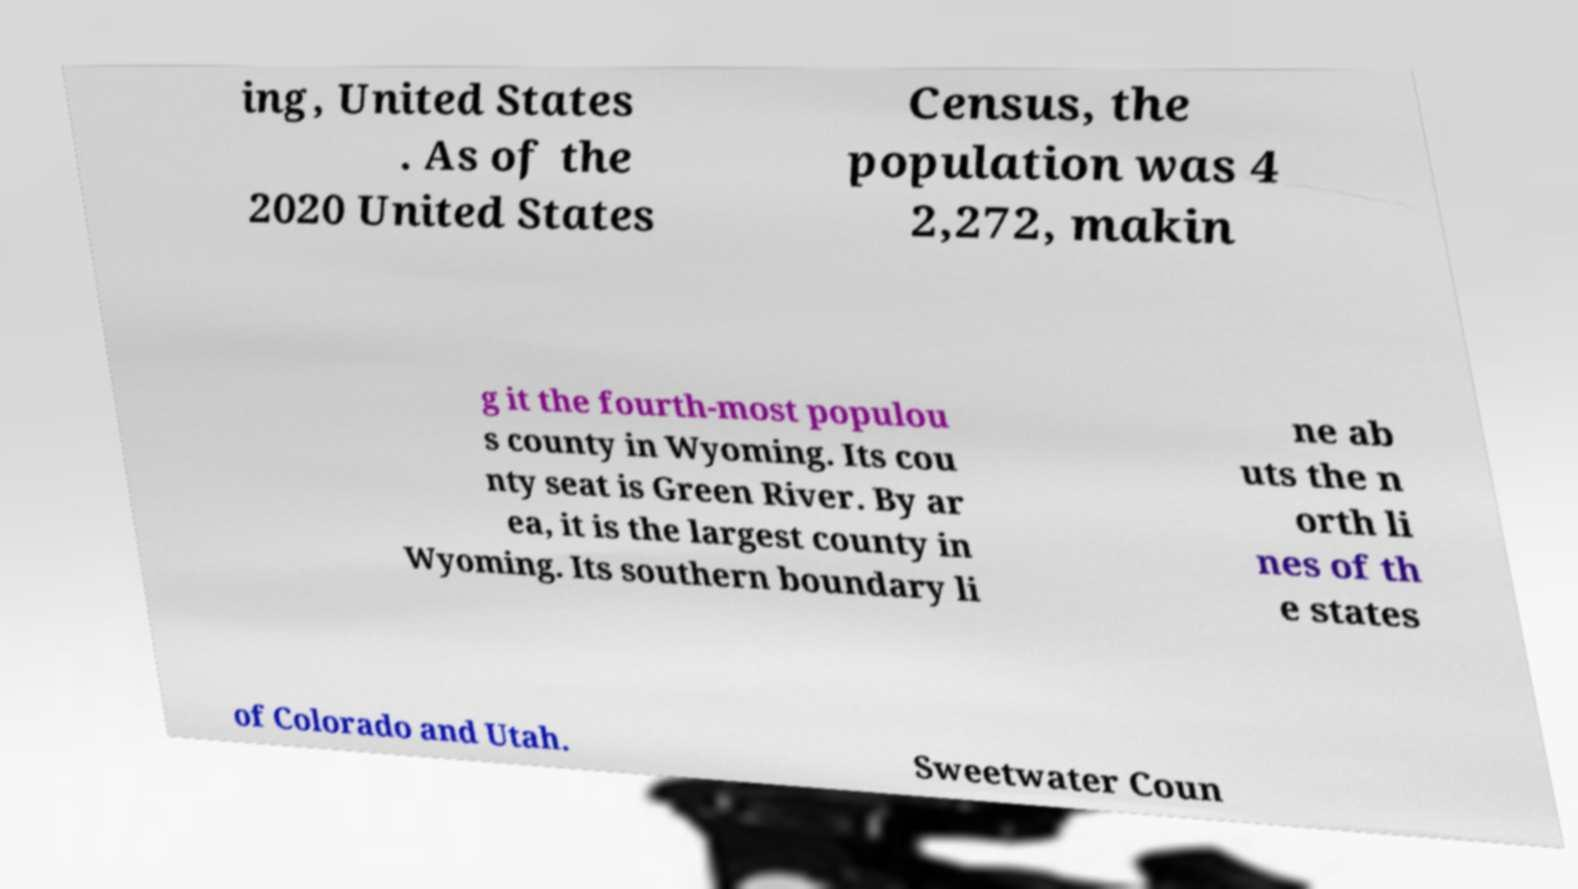Can you accurately transcribe the text from the provided image for me? ing, United States . As of the 2020 United States Census, the population was 4 2,272, makin g it the fourth-most populou s county in Wyoming. Its cou nty seat is Green River. By ar ea, it is the largest county in Wyoming. Its southern boundary li ne ab uts the n orth li nes of th e states of Colorado and Utah. Sweetwater Coun 